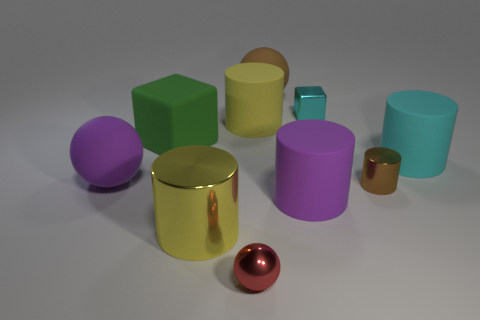Subtract all small red balls. How many balls are left? 2 Subtract all purple cylinders. How many cylinders are left? 4 Subtract all spheres. How many objects are left? 7 Subtract 1 cyan cylinders. How many objects are left? 9 Subtract 2 balls. How many balls are left? 1 Subtract all cyan spheres. Subtract all green cubes. How many spheres are left? 3 Subtract all yellow cylinders. How many gray cubes are left? 0 Subtract all large cyan spheres. Subtract all big matte cylinders. How many objects are left? 7 Add 1 yellow metal cylinders. How many yellow metal cylinders are left? 2 Add 6 cyan matte cylinders. How many cyan matte cylinders exist? 7 